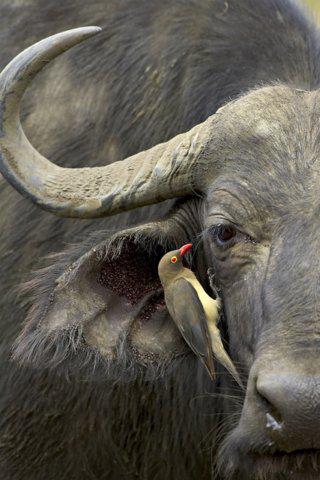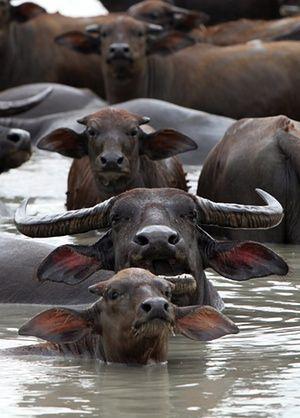The first image is the image on the left, the second image is the image on the right. For the images displayed, is the sentence "The left image contains at least two water buffalo." factually correct? Answer yes or no. No. The first image is the image on the left, the second image is the image on the right. Analyze the images presented: Is the assertion "In each image, a rope can be seen threaded through the nose of at least one ox-like animal." valid? Answer yes or no. No. 